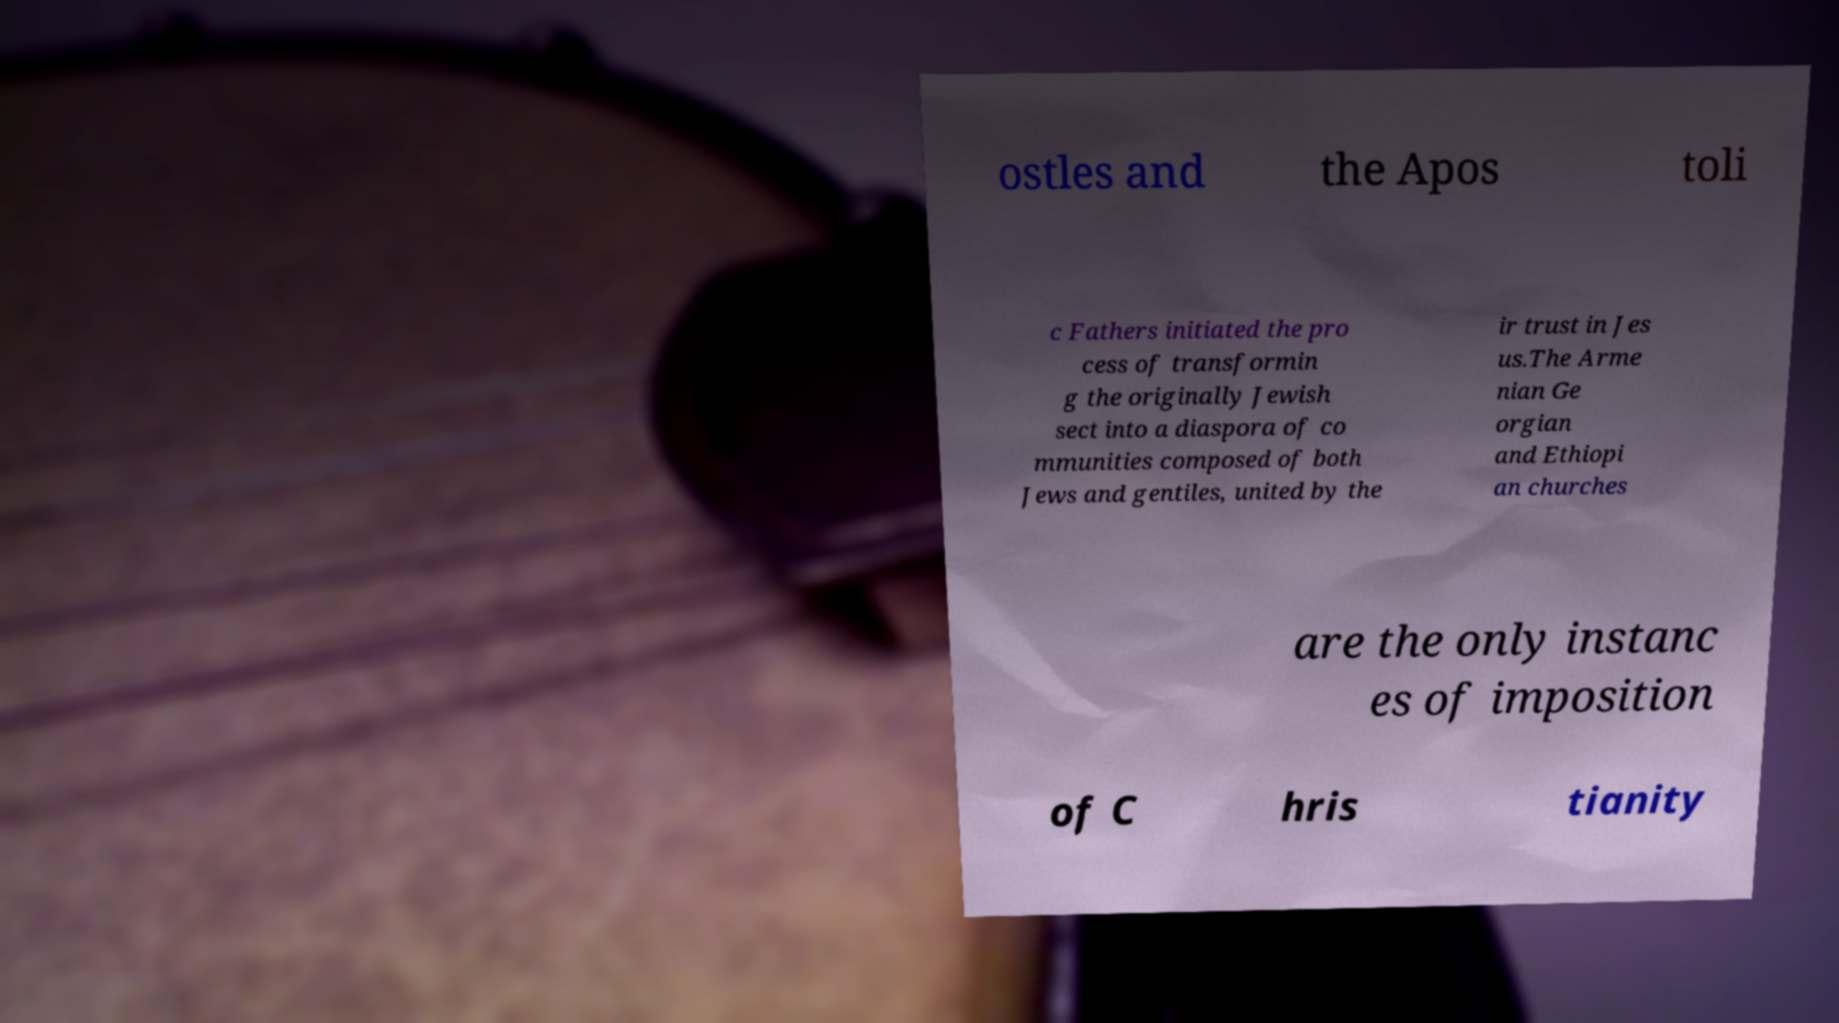I need the written content from this picture converted into text. Can you do that? ostles and the Apos toli c Fathers initiated the pro cess of transformin g the originally Jewish sect into a diaspora of co mmunities composed of both Jews and gentiles, united by the ir trust in Jes us.The Arme nian Ge orgian and Ethiopi an churches are the only instanc es of imposition of C hris tianity 